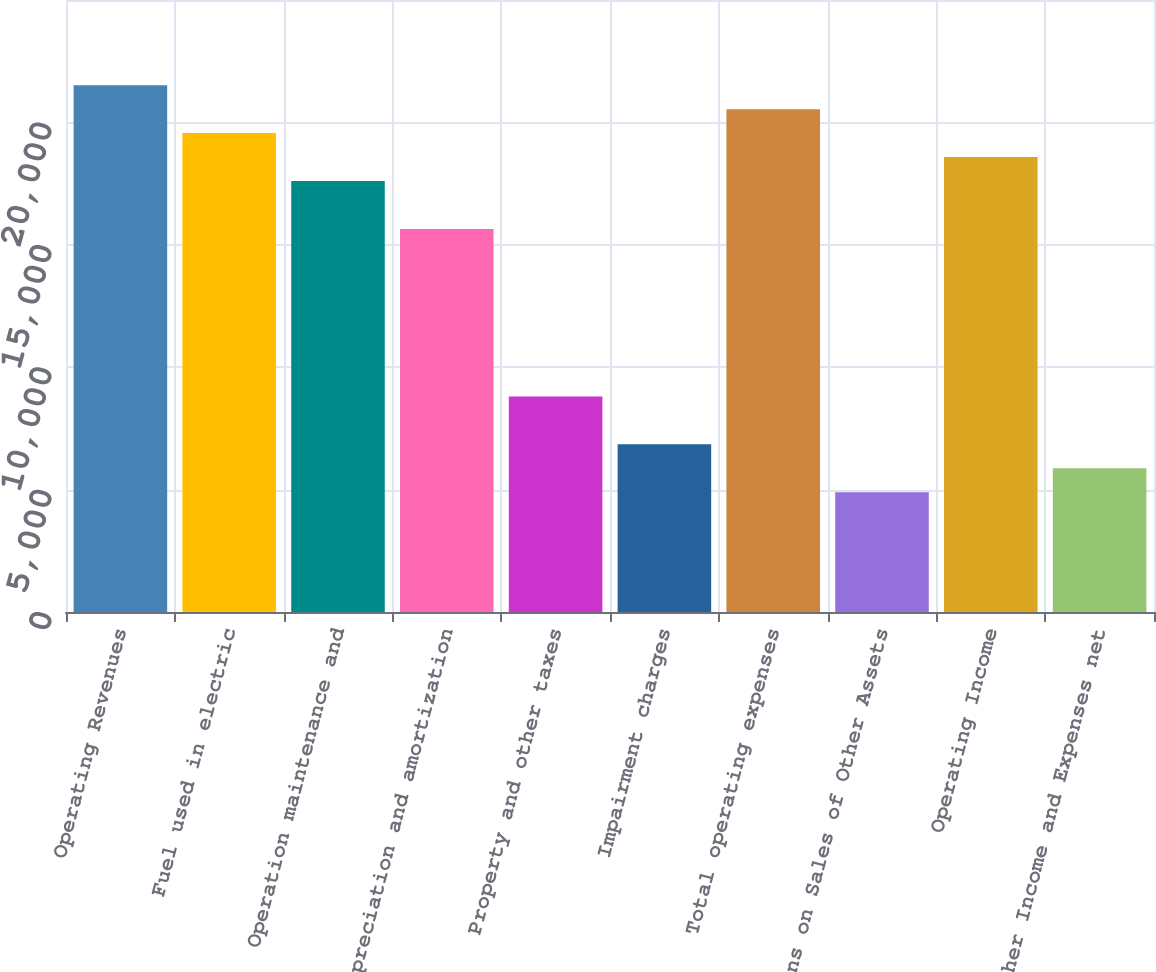Convert chart. <chart><loc_0><loc_0><loc_500><loc_500><bar_chart><fcel>Operating Revenues<fcel>Fuel used in electric<fcel>Operation maintenance and<fcel>Depreciation and amortization<fcel>Property and other taxes<fcel>Impairment charges<fcel>Total operating expenses<fcel>Gains on Sales of Other Assets<fcel>Operating Income<fcel>Other Income and Expenses net<nl><fcel>21517.8<fcel>19562<fcel>17606.2<fcel>15650.4<fcel>8805.1<fcel>6849.3<fcel>20539.9<fcel>4893.5<fcel>18584.1<fcel>5871.4<nl></chart> 